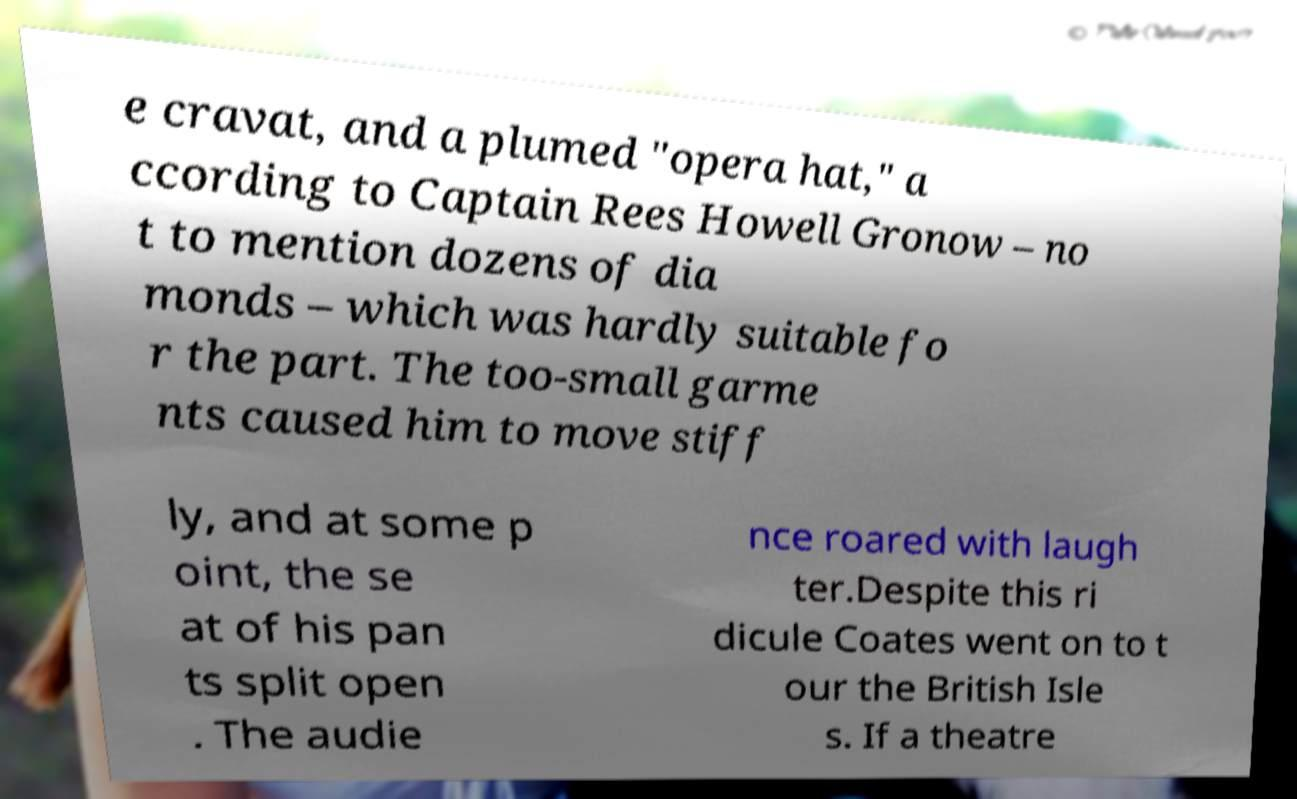Can you read and provide the text displayed in the image?This photo seems to have some interesting text. Can you extract and type it out for me? e cravat, and a plumed "opera hat," a ccording to Captain Rees Howell Gronow – no t to mention dozens of dia monds – which was hardly suitable fo r the part. The too-small garme nts caused him to move stiff ly, and at some p oint, the se at of his pan ts split open . The audie nce roared with laugh ter.Despite this ri dicule Coates went on to t our the British Isle s. If a theatre 